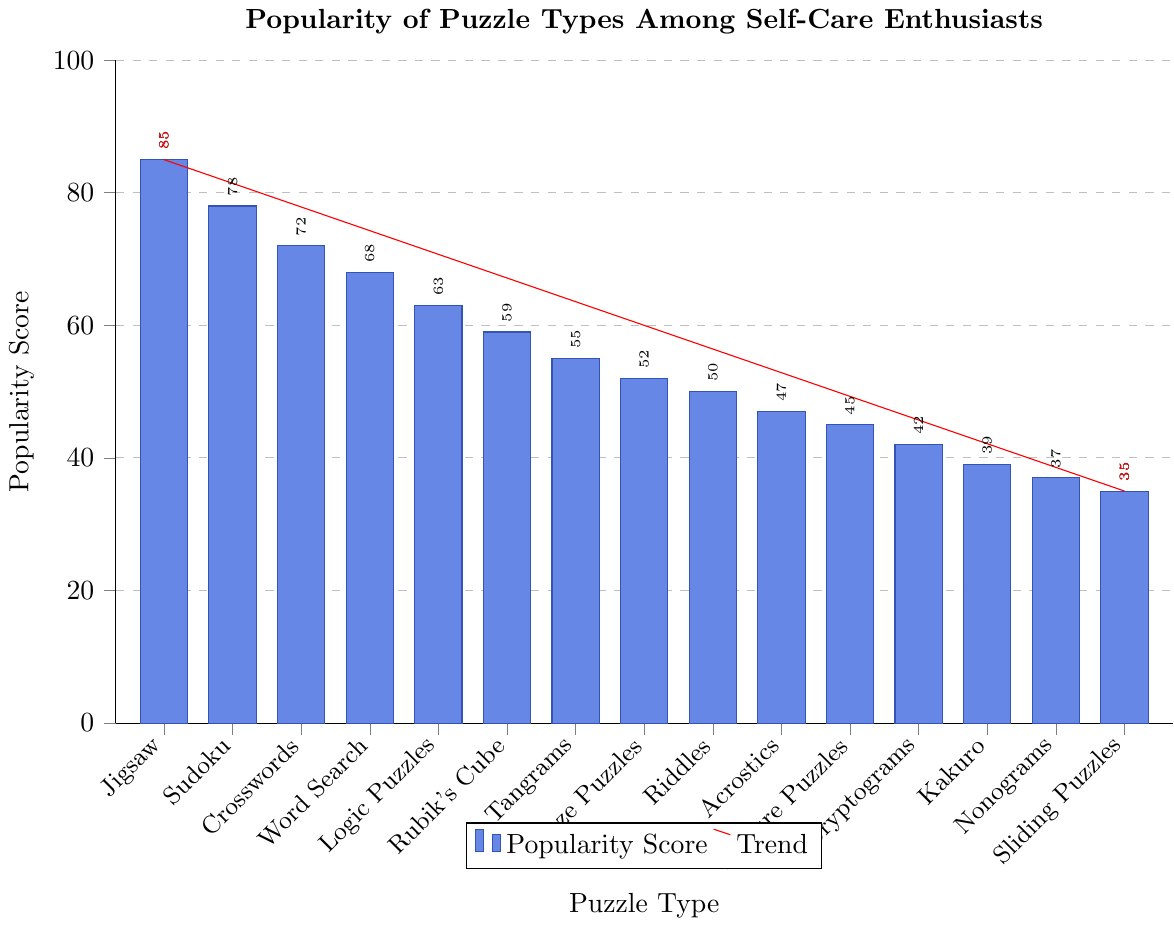Which puzzle type is the most popular among self-care enthusiasts? By looking at the bar chart, the highest bar represents the most popular puzzle type. The highest bar corresponds to Jigsaw Puzzles with a popularity score of 85.
Answer: Jigsaw Puzzles What is the difference in popularity between Sudoku and Crosswords? Find the bars for Sudoku and Crosswords, note their values (78 and 72 respectively), and subtract the smaller value from the larger value: 78 - 72.
Answer: 6 Which puzzle type is exactly in the middle of the popularity ranking? List the puzzle types by their popularity scores in descending order. The middle value in a list of 15 items is the 8th item: Jigsaw Puzzles, Sudoku, Crosswords, Word Search, Logic Puzzles, Rubik's Cube, Tangrams, Maze Puzzles.
Answer: Maze Puzzles What is the average popularity score of the top 3 most popular puzzle types? Identify the top 3 puzzle types and their scores: Jigsaw Puzzles (85), Sudoku (78), Crosswords (72). Calculate the average by summing these values and dividing by 3: (85 + 78 + 72) / 3.
Answer: 78.33 How many puzzle types have a popularity score above 50? Count the number of bars with values above 50. The puzzle types are Jigsaw Puzzles, Sudoku, Crosswords, Word Search, Logic Puzzles, Rubik's Cube, Tangrams, and Maze Puzzles. There are 8 such bars.
Answer: 8 Which puzzle type has a popularity score closest to 60? Look at the bars around the value 60. Rubik's Cube has a score of 59, which is the closest to 60.
Answer: Rubik's Cube What is the combined popularity score of all the puzzles with scores below 50? Identify all puzzle types with values below 50: Acrostics (47), Picture Puzzles (45), Cryptograms (42), Kakuro (39), Nonograms (37), Sliding Puzzles (35). Sum their values: 47 + 45 + 42 + 39 + 37 + 35.
Answer: 245 Which puzzle type has the smallest popularity score, and what is it? Identify the bar with the smallest height, which represents the puzzle type with the lowest popularity score. This corresponds to Sliding Puzzles with a score of 35.
Answer: Sliding Puzzles, 35 